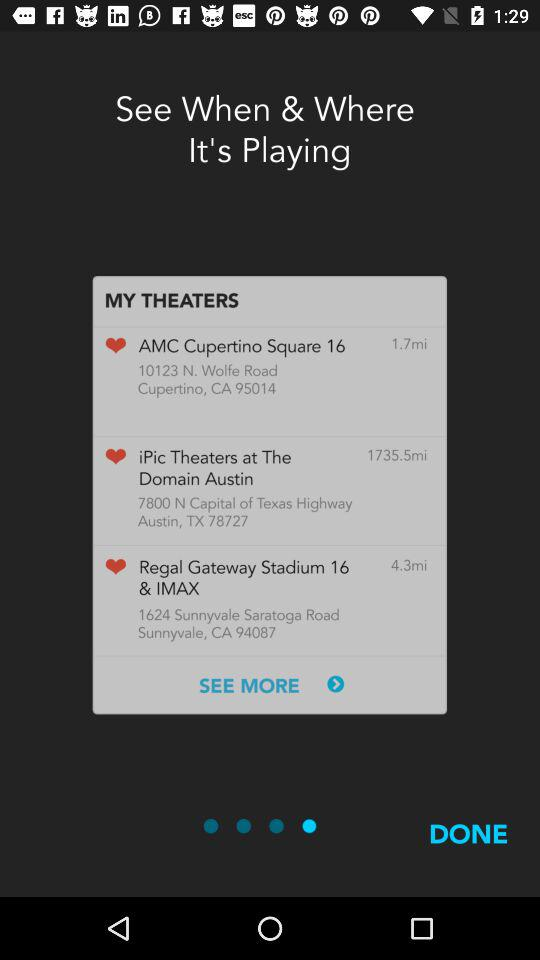How many miles away is the theater with the shortest distance?
Answer the question using a single word or phrase. 1.7 